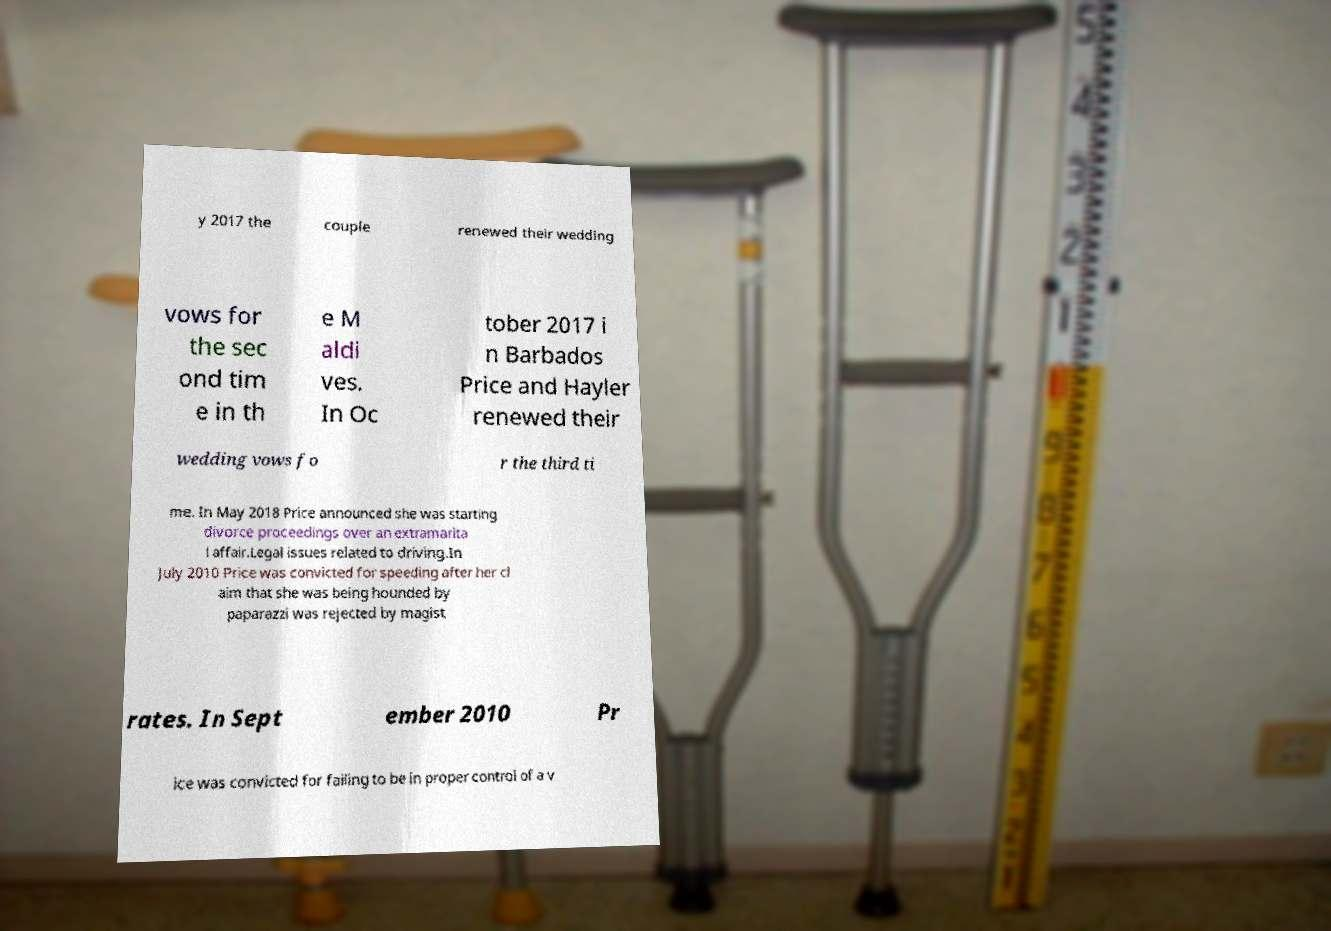For documentation purposes, I need the text within this image transcribed. Could you provide that? y 2017 the couple renewed their wedding vows for the sec ond tim e in th e M aldi ves. In Oc tober 2017 i n Barbados Price and Hayler renewed their wedding vows fo r the third ti me. In May 2018 Price announced she was starting divorce proceedings over an extramarita l affair.Legal issues related to driving.In July 2010 Price was convicted for speeding after her cl aim that she was being hounded by paparazzi was rejected by magist rates. In Sept ember 2010 Pr ice was convicted for failing to be in proper control of a v 